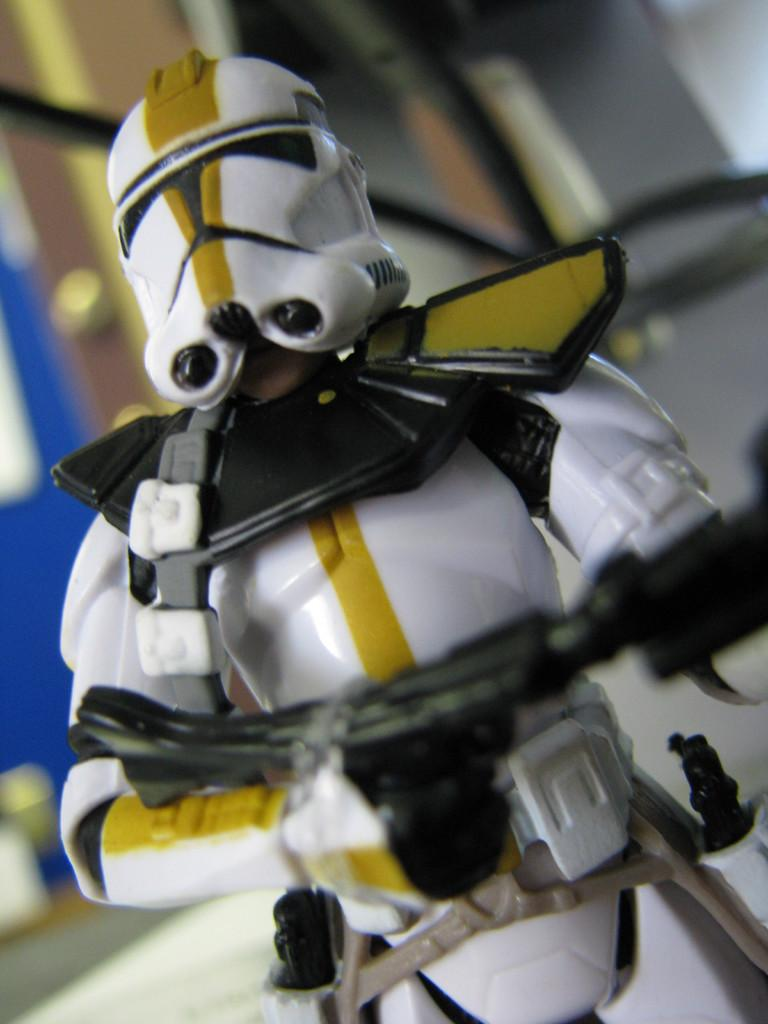What is the color of the toy in the image? The toy in the image is white. What is the toy holding in the image? The white color toy is holding a black color object. What type of gun is the toy using in the image? There is no gun present in the image; the toy is holding a black color object. What effect does the rail have on the toy in the image? There is no rail present in the image, so it cannot have any effect on the toy. 